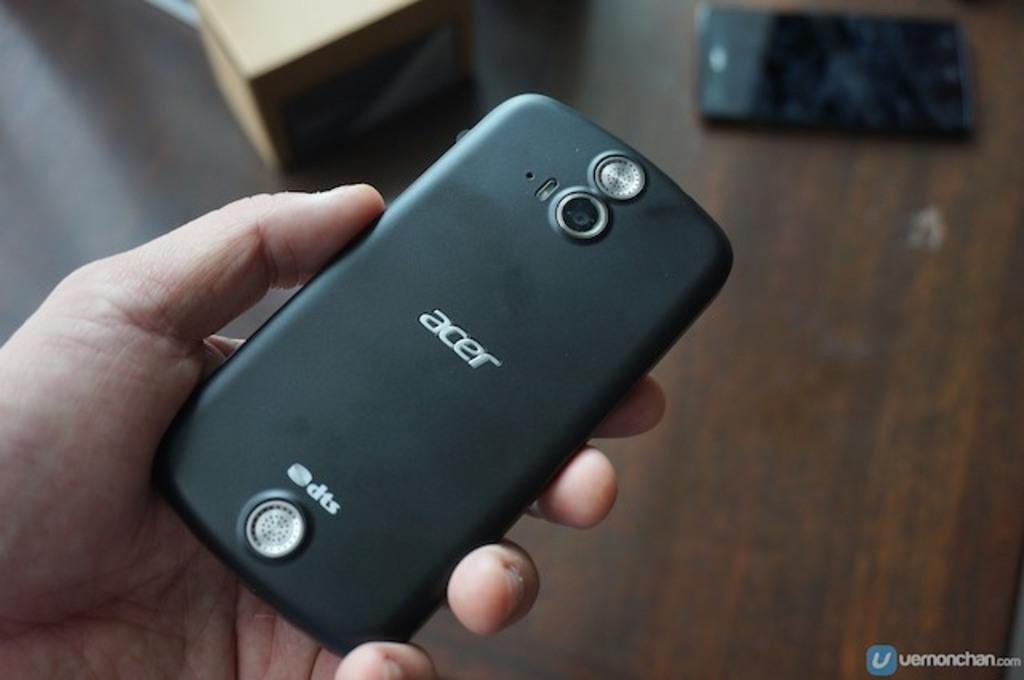Provide a one-sentence caption for the provided image. A man is holding a black Acer smart phone. 